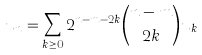Convert formula to latex. <formula><loc_0><loc_0><loc_500><loc_500>u _ { n } = \sum _ { k \geq 0 } 2 ^ { n - m - 2 k } \binom { n - m } { 2 k } u _ { k }</formula> 